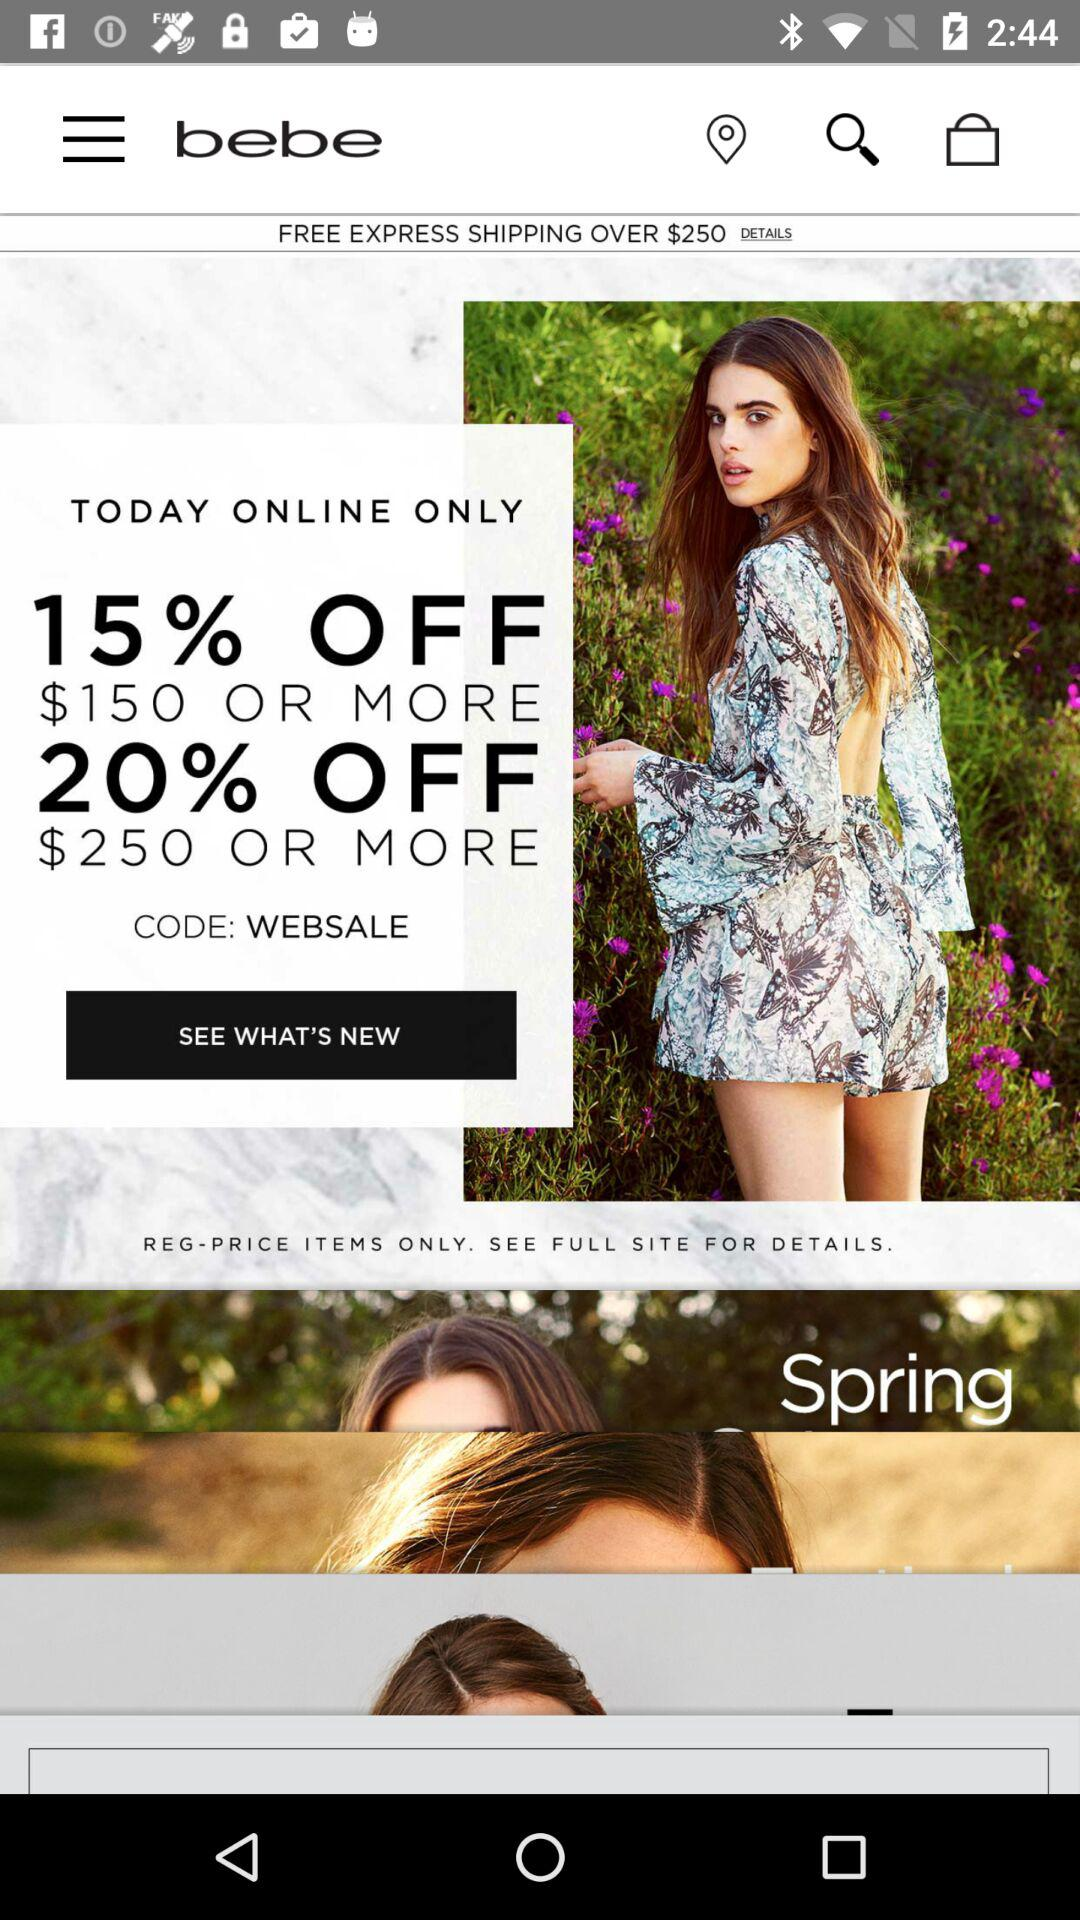What is the code for today's sale? The code for sale is WEBSALE. 